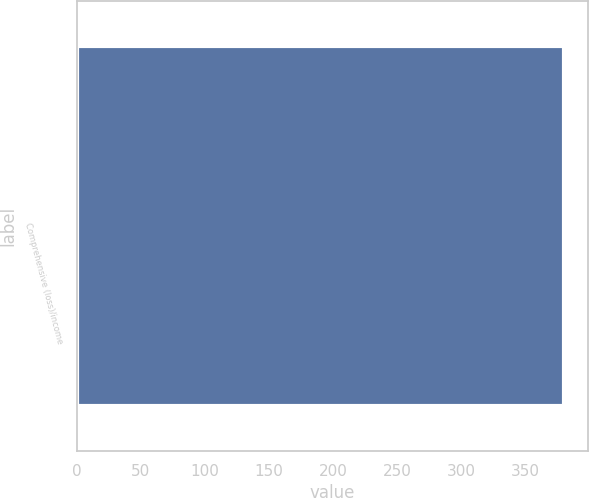Convert chart. <chart><loc_0><loc_0><loc_500><loc_500><bar_chart><fcel>Comprehensive (loss)/income<nl><fcel>380.1<nl></chart> 